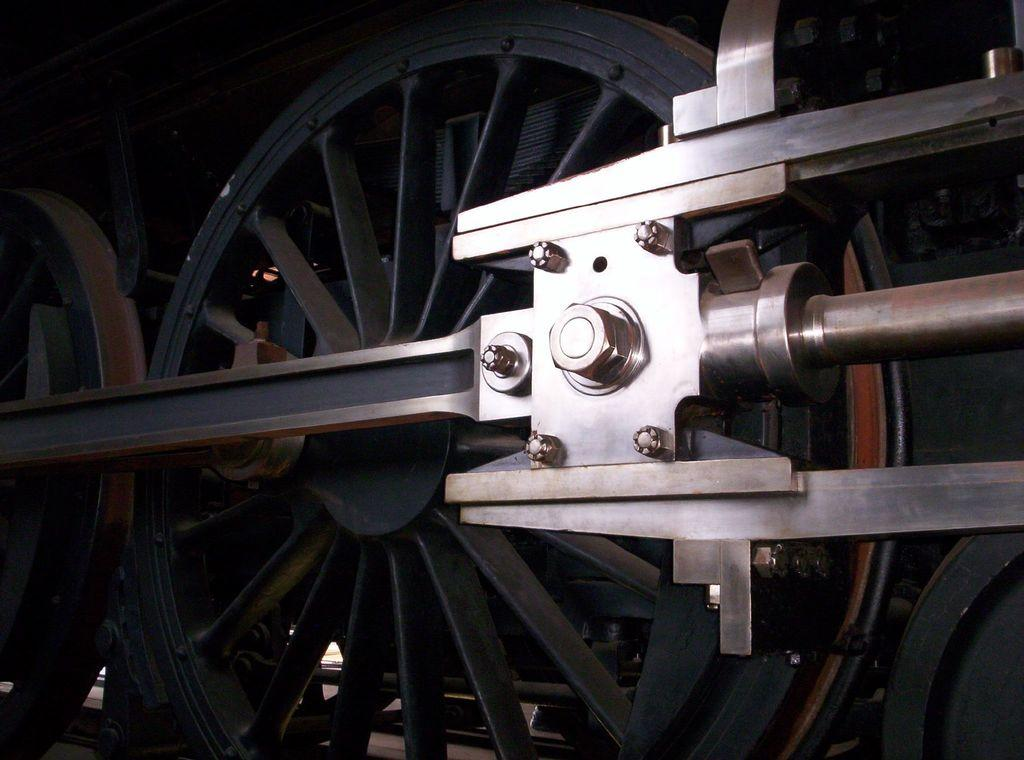What type of object or structure is depicted in the image? The image shows wheels, bolts, and rods, which suggests a mechanical or industrial object. Can you describe any specific features of the object? Yes, the object has wheels, bolts, and rods visible in the image. How many women are visible in the image? There are no women present in the image; it features mechanical or industrial components. Can you describe the leg of the object in the image? There is no specific leg of the object mentioned in the image, as it only shows wheels, bolts, and rods. 